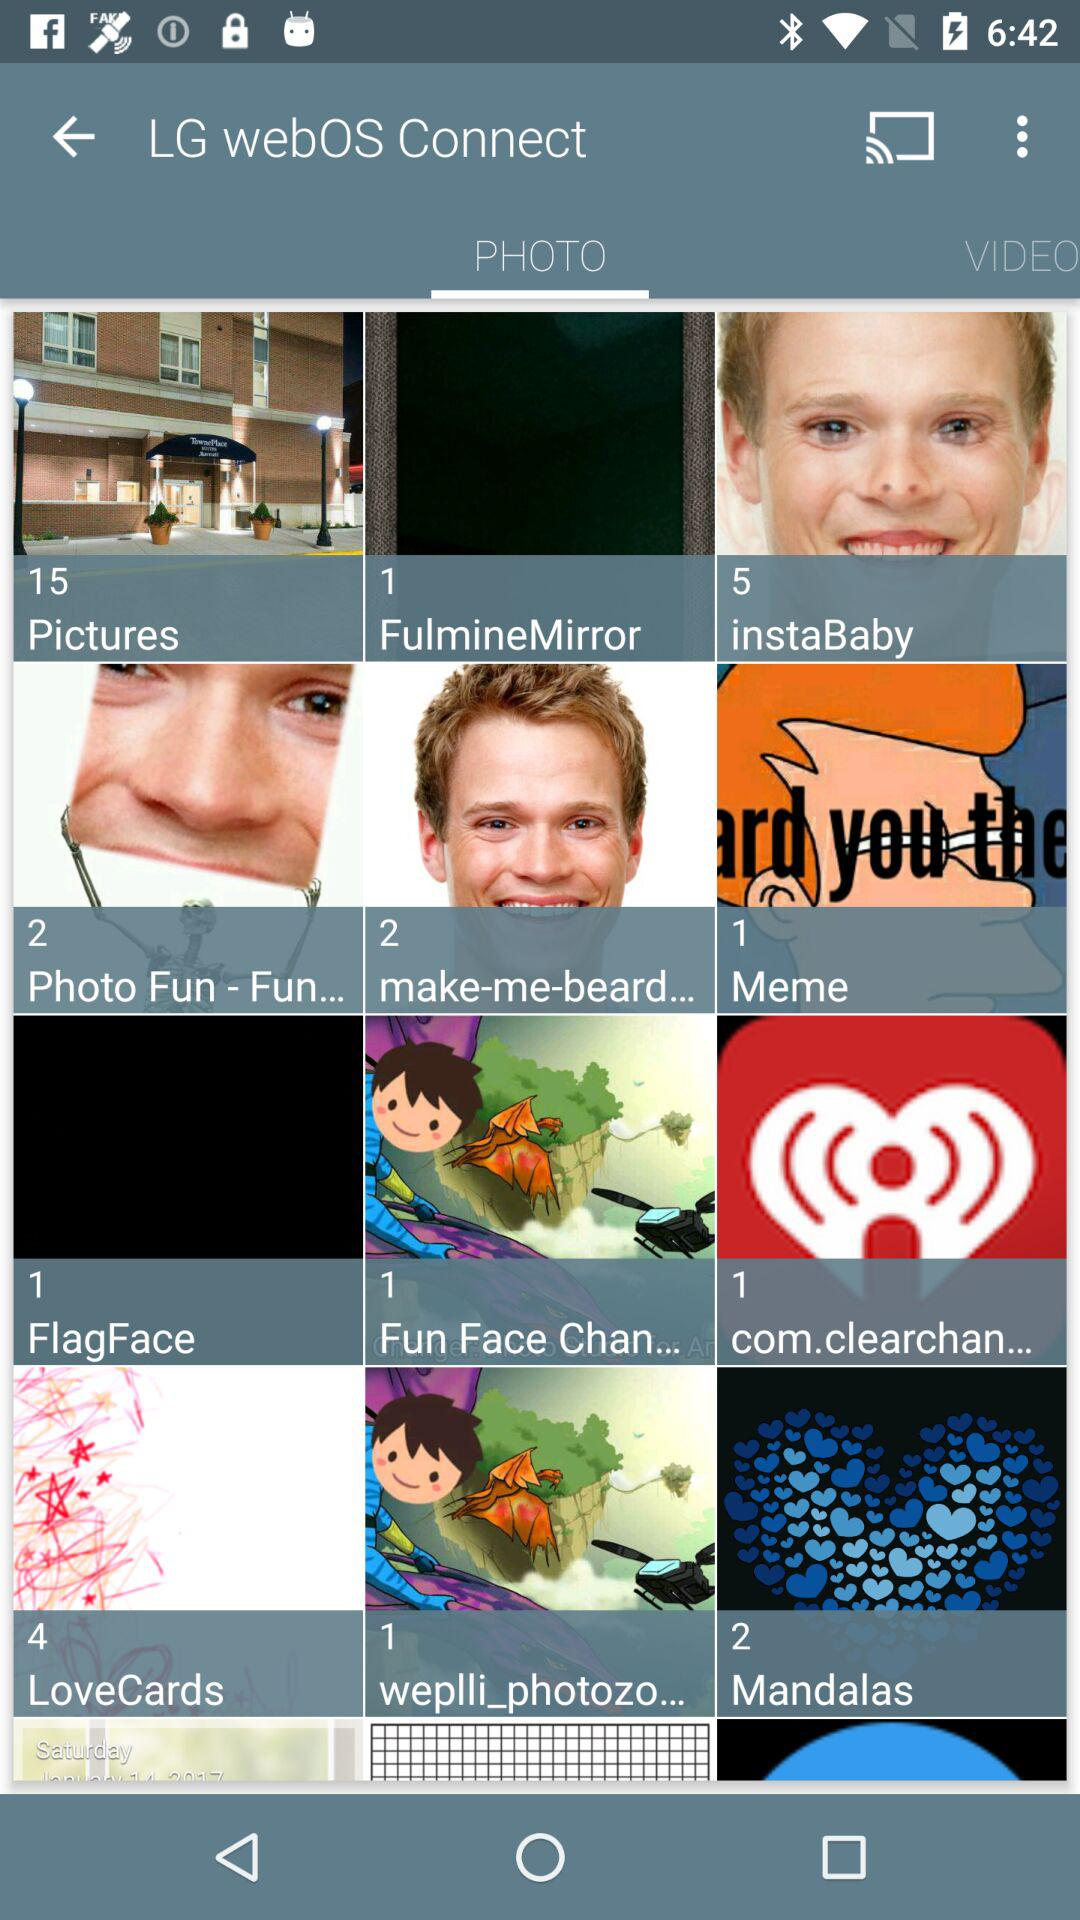Which tab is selected? The selected tab is "PHOTO". 